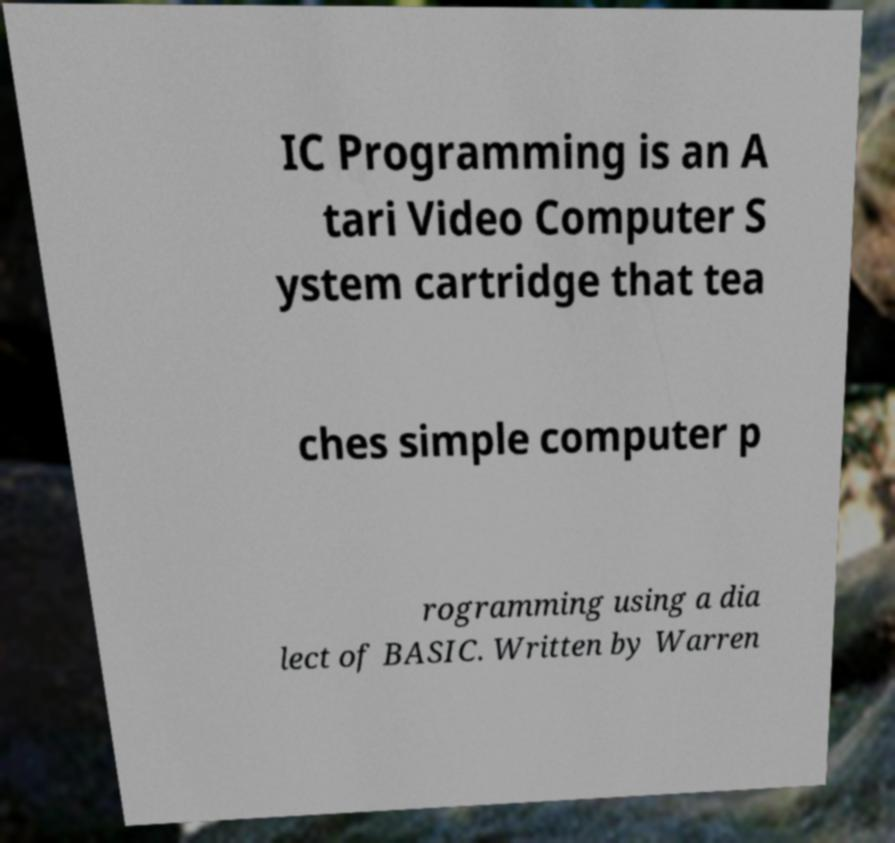For documentation purposes, I need the text within this image transcribed. Could you provide that? IC Programming is an A tari Video Computer S ystem cartridge that tea ches simple computer p rogramming using a dia lect of BASIC. Written by Warren 